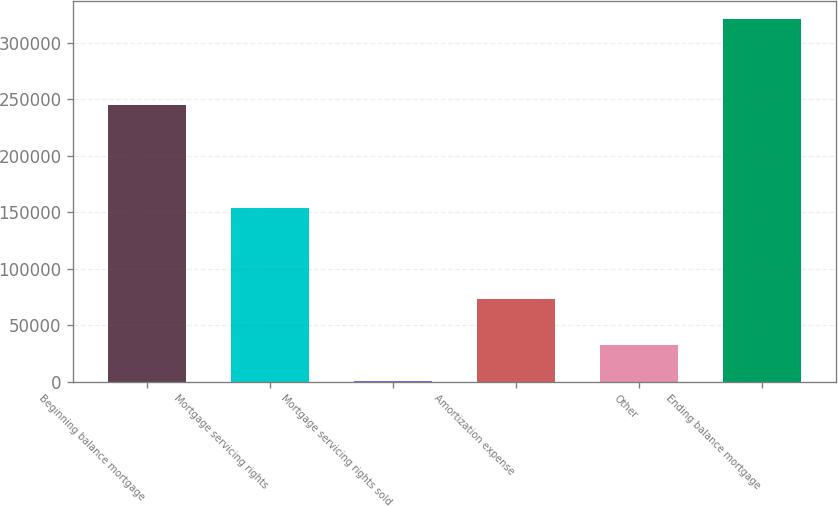Convert chart to OTSL. <chart><loc_0><loc_0><loc_500><loc_500><bar_chart><fcel>Beginning balance mortgage<fcel>Mortgage servicing rights<fcel>Mortgage servicing rights sold<fcel>Amortization expense<fcel>Other<fcel>Ending balance mortgage<nl><fcel>244723<fcel>154040<fcel>790<fcel>73273<fcel>32763.4<fcel>320524<nl></chart> 